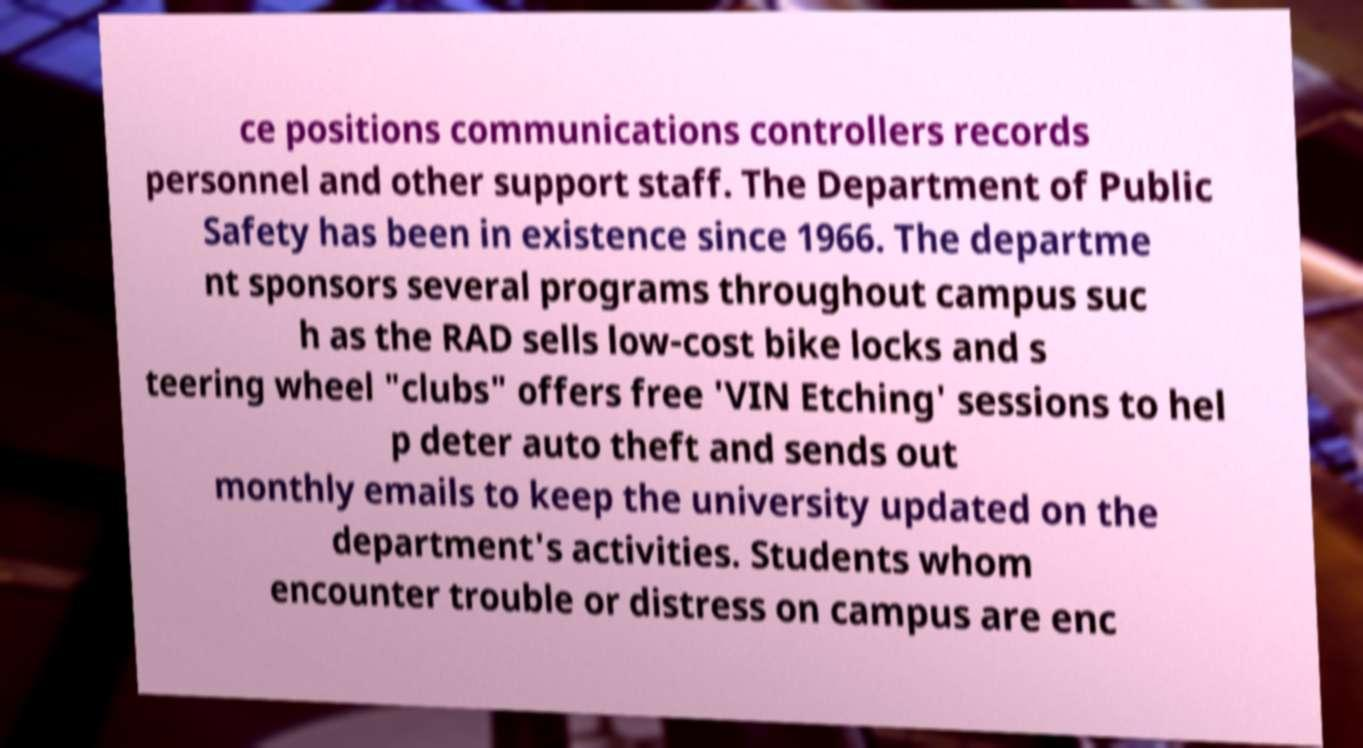Could you assist in decoding the text presented in this image and type it out clearly? ce positions communications controllers records personnel and other support staff. The Department of Public Safety has been in existence since 1966. The departme nt sponsors several programs throughout campus suc h as the RAD sells low-cost bike locks and s teering wheel "clubs" offers free 'VIN Etching' sessions to hel p deter auto theft and sends out monthly emails to keep the university updated on the department's activities. Students whom encounter trouble or distress on campus are enc 